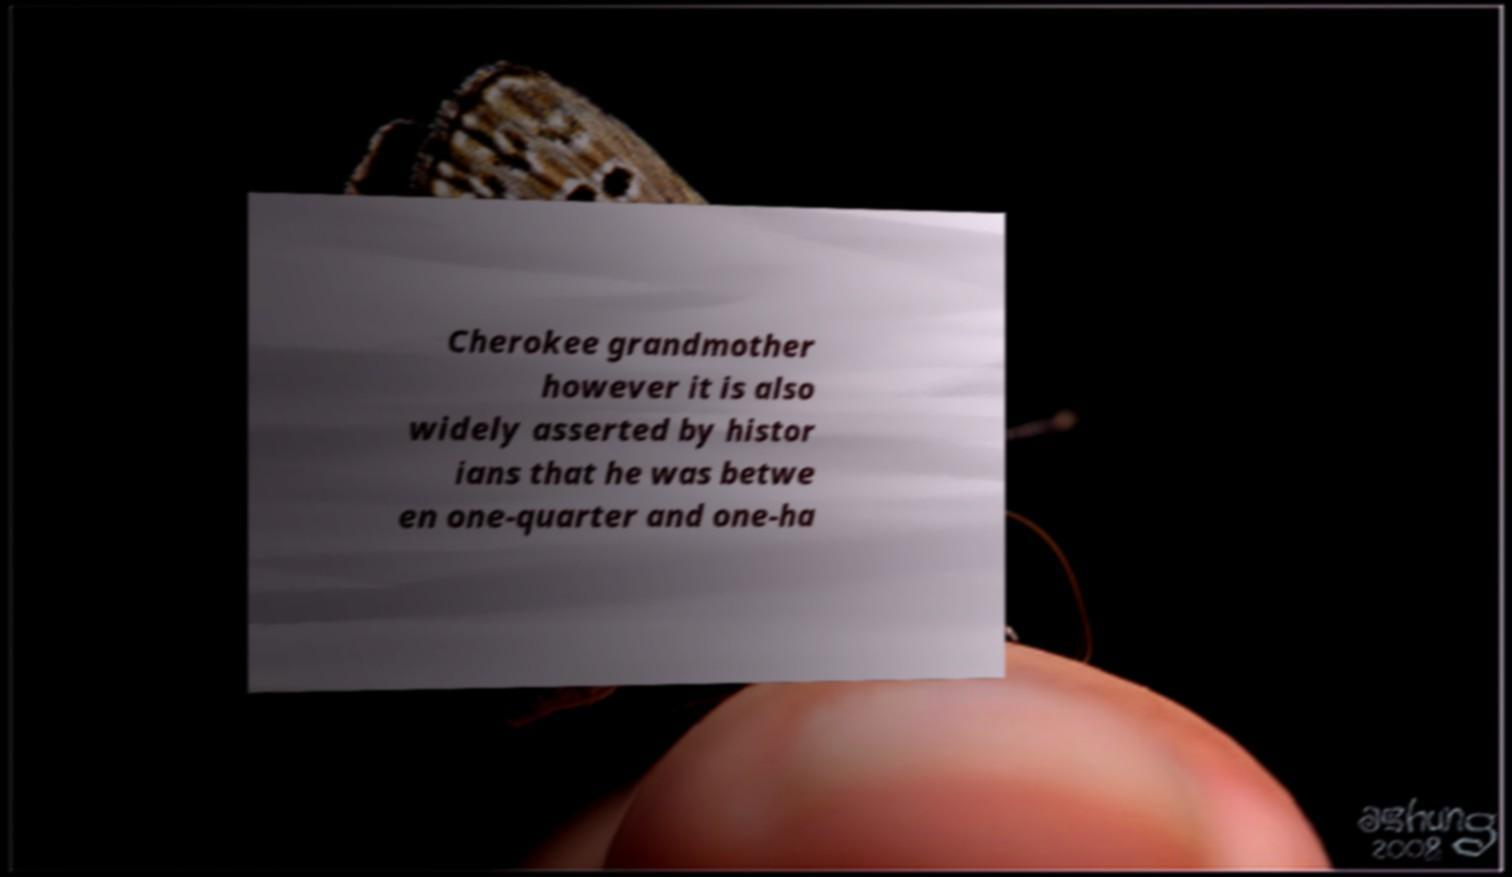Can you read and provide the text displayed in the image?This photo seems to have some interesting text. Can you extract and type it out for me? Cherokee grandmother however it is also widely asserted by histor ians that he was betwe en one-quarter and one-ha 